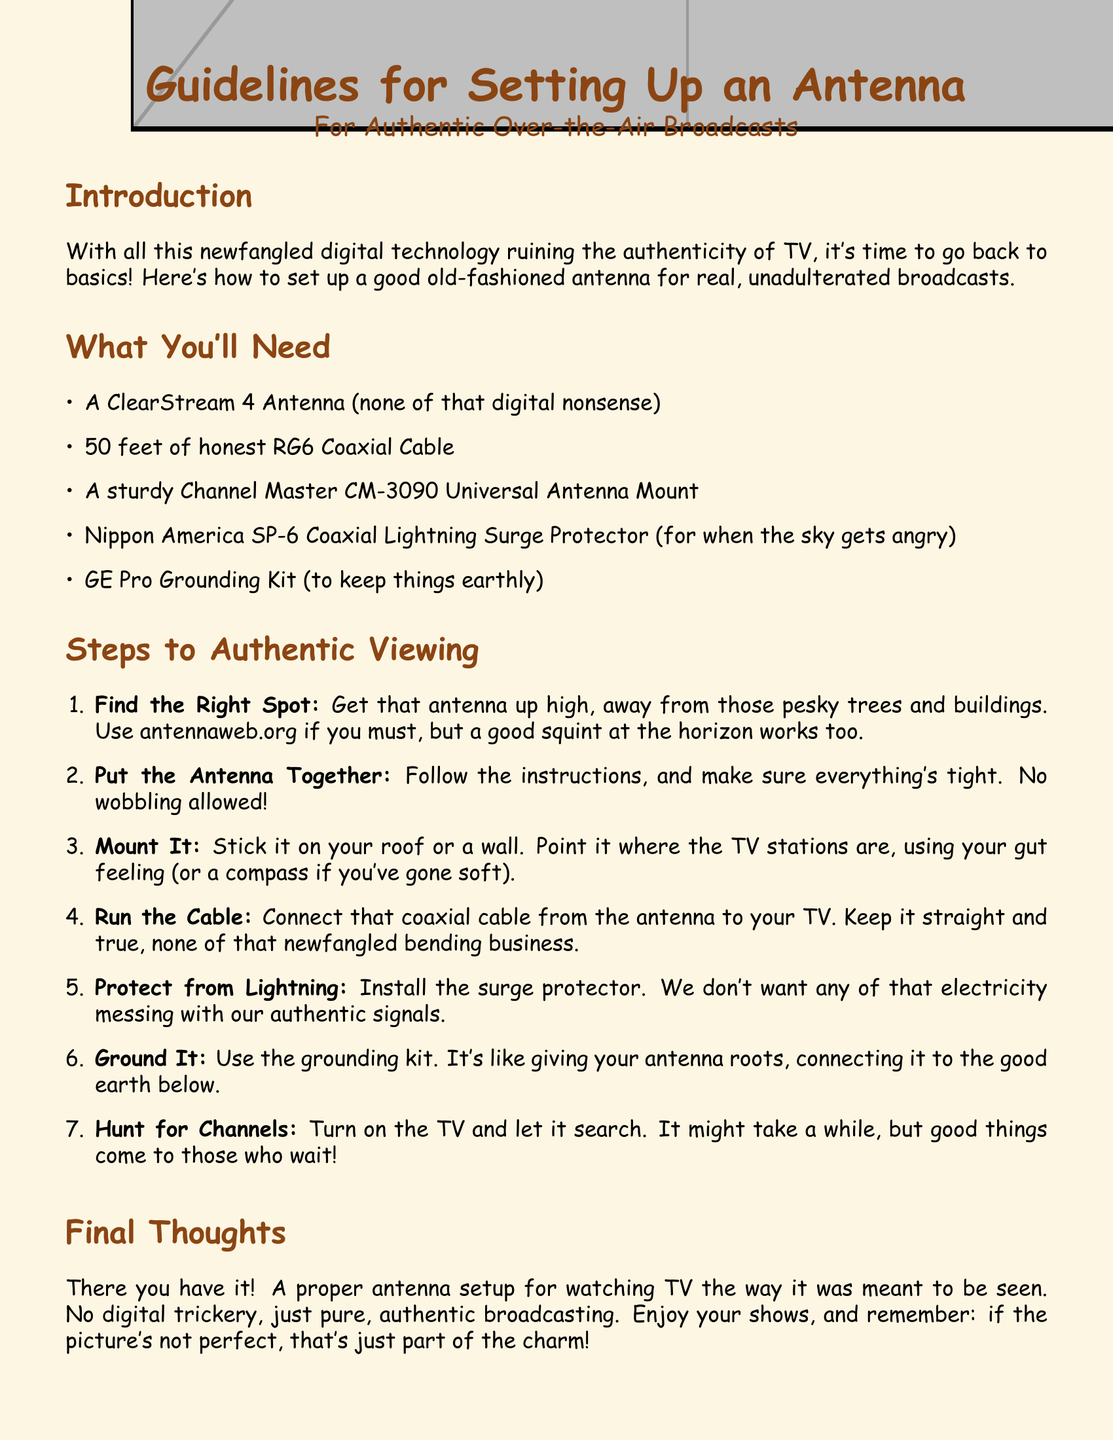What kind of antenna is recommended? The document suggests using a ClearStream 4 Antenna.
Answer: ClearStream 4 Antenna How long should the coaxial cable be? The guidelines specify using 50 feet of coaxial cable.
Answer: 50 feet What is the purpose of the surge protector? The surge protector is mentioned for protection from lightning.
Answer: Protect from lightning Which website can help find the right antenna spot? The document mentions antennaweb.org as a resource.
Answer: antennaweb.org What should you do to ensure the antenna is safe from lightning? The instructions suggest installing the surge protector for safety.
Answer: Install the surge protector Where should the antenna be mounted? The document recommends mounting it on the roof or a wall.
Answer: Roof or wall What should you do when you turn on the TV? You should let the TV search for channels.
Answer: Search for channels What type of grounding kit is recommended? A GE Pro Grounding Kit is advised in the document.
Answer: GE Pro Grounding Kit What is the last step in setting up the antenna? The last step is to hunt for channels on the TV.
Answer: Hunt for channels 